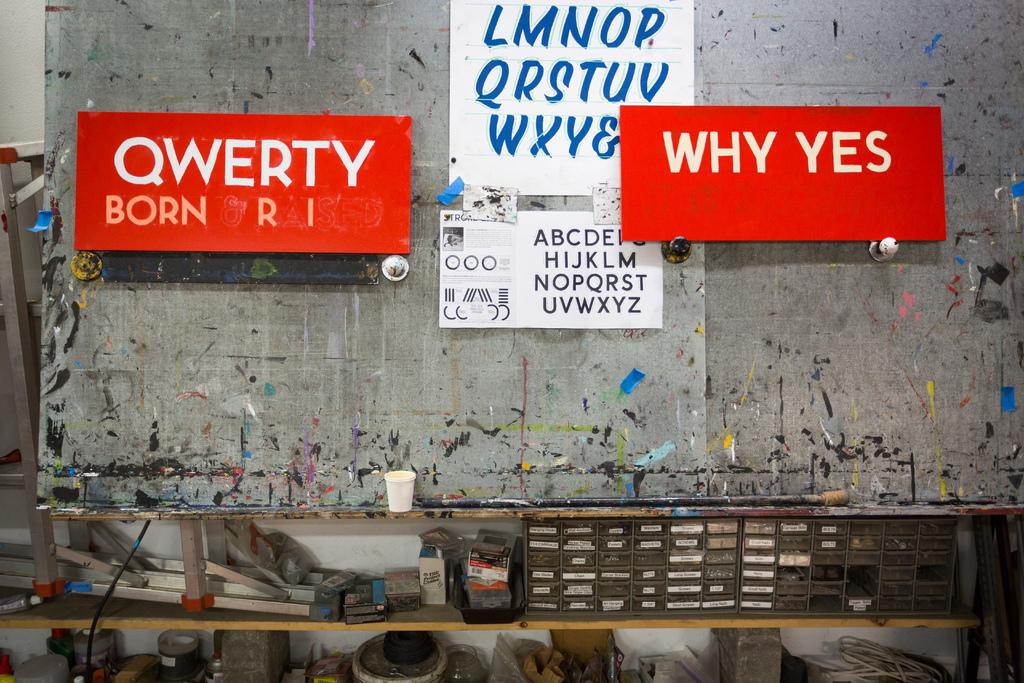Provide a one-sentence caption for the provided image. A large red sign that states "Why Yes" is hanging near two other signs on a wall. 